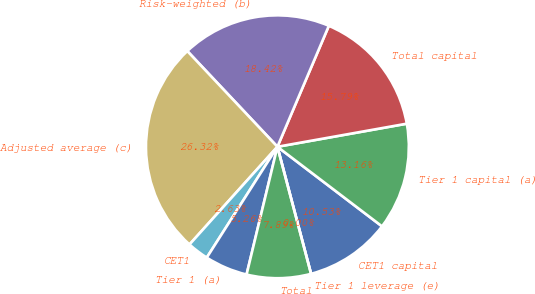Convert chart to OTSL. <chart><loc_0><loc_0><loc_500><loc_500><pie_chart><fcel>CET1 capital<fcel>Tier 1 capital (a)<fcel>Total capital<fcel>Risk-weighted (b)<fcel>Adjusted average (c)<fcel>CET1<fcel>Tier 1 (a)<fcel>Total<fcel>Tier 1 leverage (e)<nl><fcel>10.53%<fcel>13.16%<fcel>15.79%<fcel>18.42%<fcel>26.32%<fcel>2.63%<fcel>5.26%<fcel>7.89%<fcel>0.0%<nl></chart> 